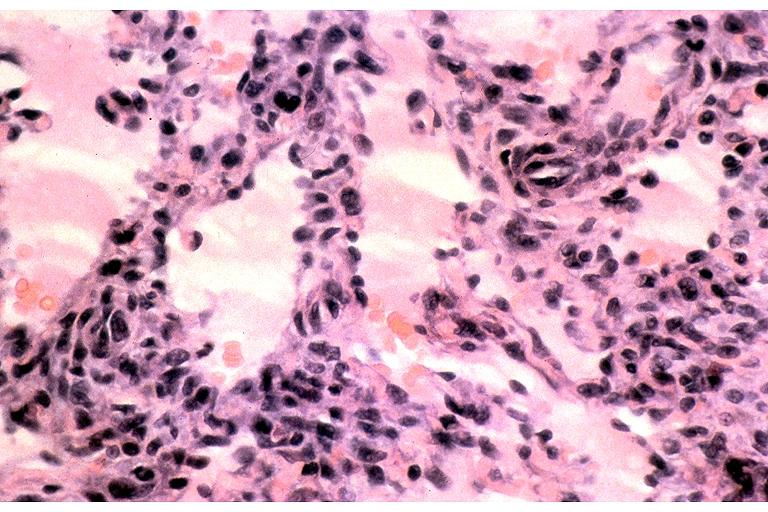does postpartum uterus show kaposi sarcoma?
Answer the question using a single word or phrase. No 